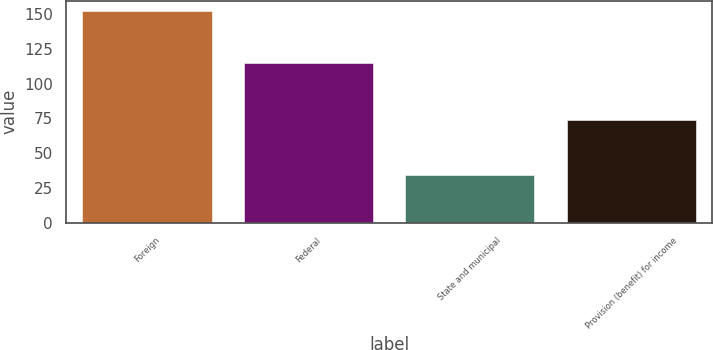Convert chart to OTSL. <chart><loc_0><loc_0><loc_500><loc_500><bar_chart><fcel>Foreign<fcel>Federal<fcel>State and municipal<fcel>Provision (benefit) for income<nl><fcel>152<fcel>115<fcel>34<fcel>74<nl></chart> 